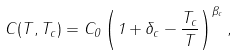Convert formula to latex. <formula><loc_0><loc_0><loc_500><loc_500>C ( T , T _ { c } ) = C _ { 0 } \left ( 1 + \delta _ { c } - \frac { T _ { c } } { T } \right ) ^ { \beta _ { c } } ,</formula> 